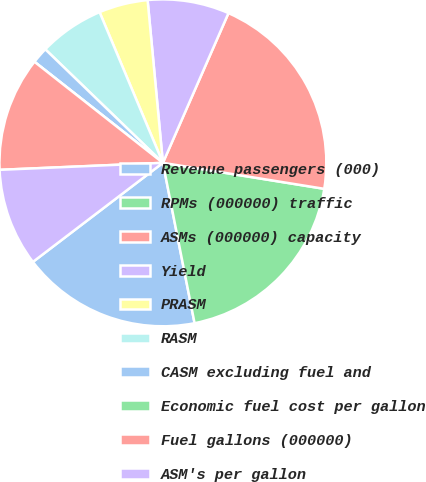<chart> <loc_0><loc_0><loc_500><loc_500><pie_chart><fcel>Revenue passengers (000)<fcel>RPMs (000000) traffic<fcel>ASMs (000000) capacity<fcel>Yield<fcel>PRASM<fcel>RASM<fcel>CASM excluding fuel and<fcel>Economic fuel cost per gallon<fcel>Fuel gallons (000000)<fcel>ASM's per gallon<nl><fcel>17.74%<fcel>19.35%<fcel>20.97%<fcel>8.06%<fcel>4.84%<fcel>6.45%<fcel>1.61%<fcel>0.0%<fcel>11.29%<fcel>9.68%<nl></chart> 